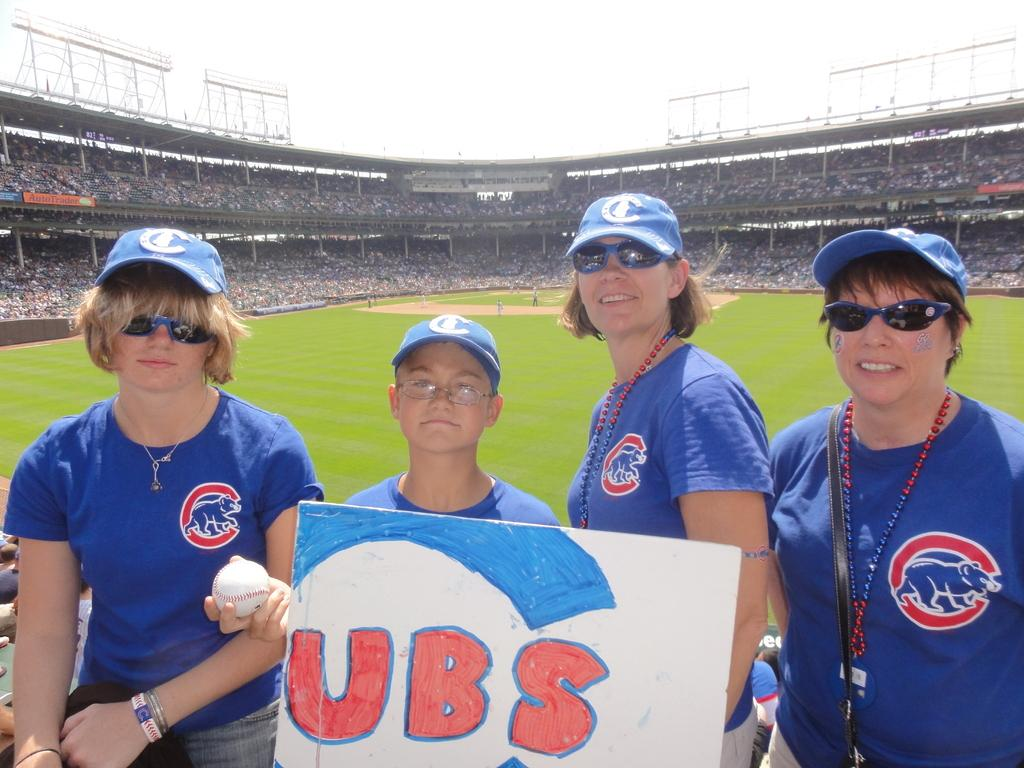<image>
Describe the image concisely. People posing for a photo with a boy holding a sign for CUBS. 